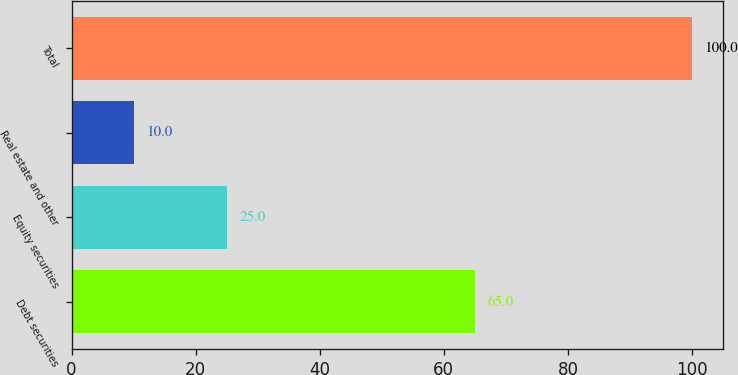Convert chart to OTSL. <chart><loc_0><loc_0><loc_500><loc_500><bar_chart><fcel>Debt securities<fcel>Equity securities<fcel>Real estate and other<fcel>Total<nl><fcel>65<fcel>25<fcel>10<fcel>100<nl></chart> 